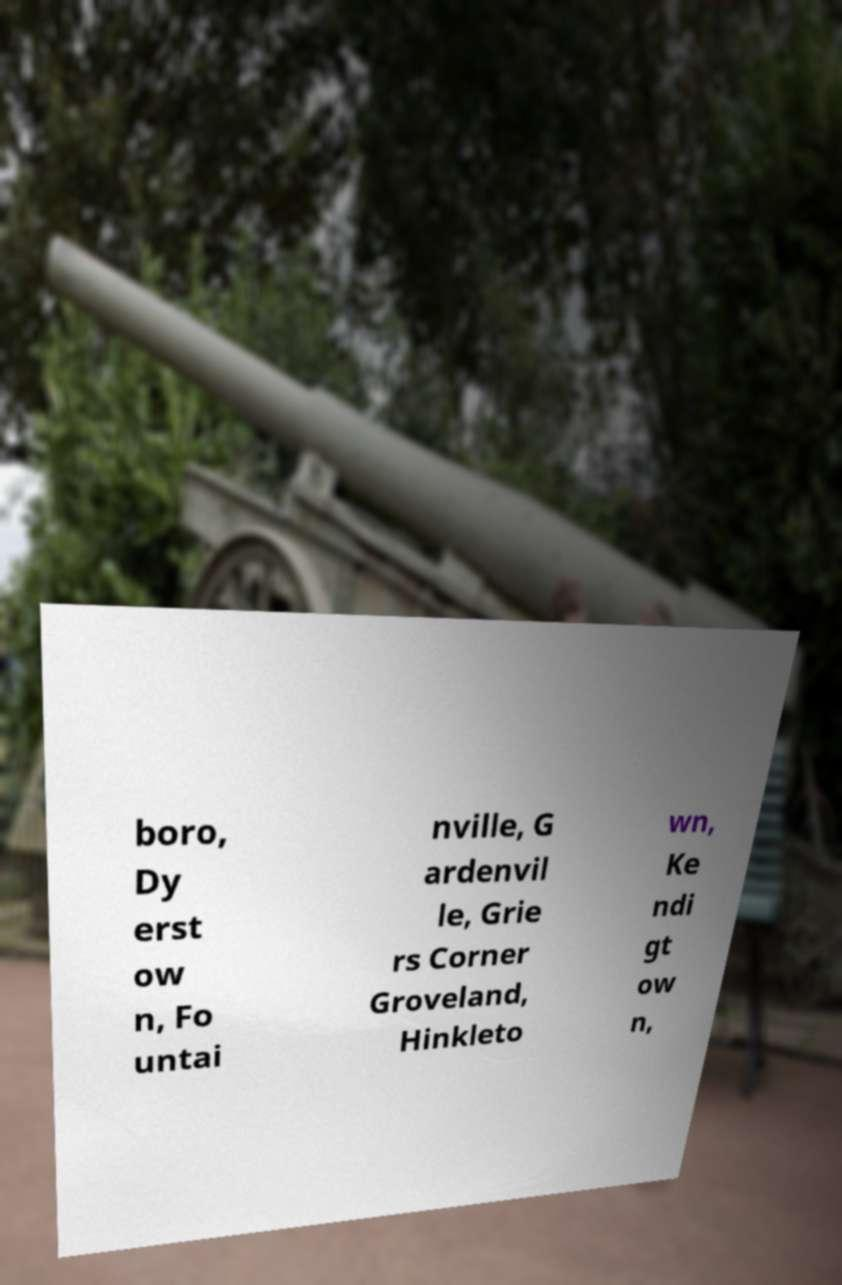For documentation purposes, I need the text within this image transcribed. Could you provide that? boro, Dy erst ow n, Fo untai nville, G ardenvil le, Grie rs Corner Groveland, Hinkleto wn, Ke ndi gt ow n, 